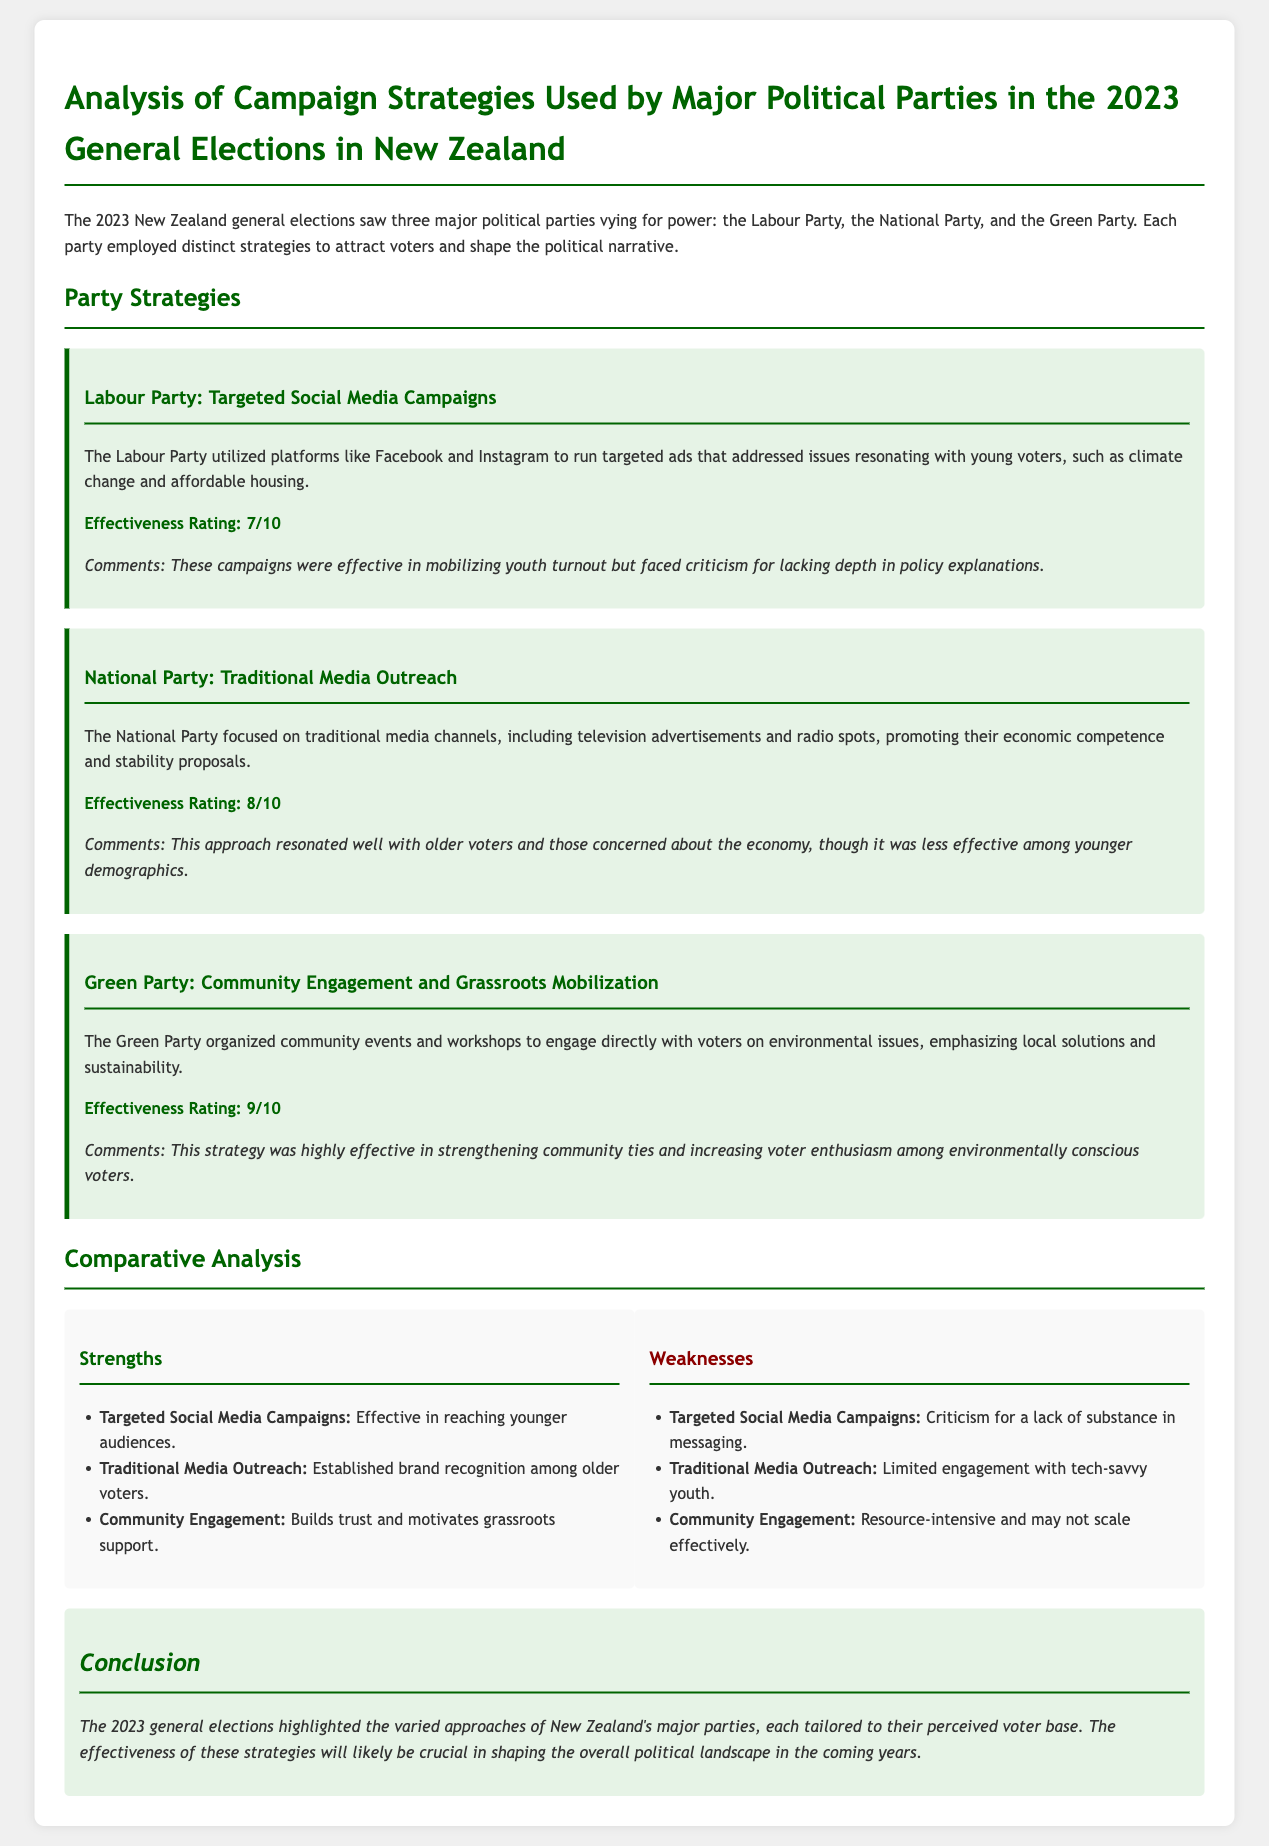What campaign strategy did the Labour Party use? The document states that the Labour Party utilized targeted social media campaigns to attract voters.
Answer: Targeted social media campaigns What was the effectiveness rating for the National Party's campaign? According to the document, the effectiveness rating for the National Party's traditional media outreach is 8 out of 10.
Answer: 8/10 What was a notable criticism of Labour's social media campaigns? The document mentions that Labour's targeted social media campaigns faced criticism for lacking depth in policy explanations.
Answer: Lack of depth in policy explanations Which party's strategy was rated the highest in effectiveness? The Green Party's community engagement and grassroots mobilization strategy received the highest effectiveness rating in the document.
Answer: Green Party What specific voter demographic did the Labour Party target? The document indicates that the Labour Party's campaigns were aimed particularly at young voters.
Answer: Young voters What is a weakness associated with the Green Party's campaign strategy? The document notes that the Green Party's community engagement strategy is resource-intensive and may not scale effectively.
Answer: Resource-intensive Which medium did the National Party emphasize in their campaign? The National Party focused on traditional media channels like television and radio for their campaign outreach.
Answer: Traditional media channels What was the primary focus of the Green Party's campaign? The document states that the Green Party organized events to engage voters directly on environmental issues.
Answer: Environmental issues 